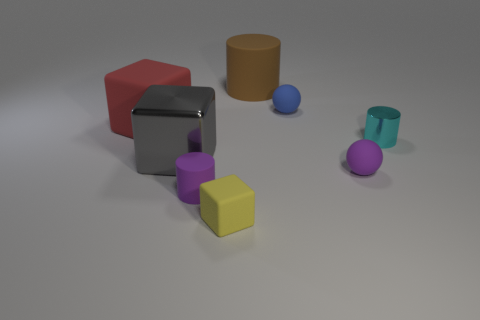What is the shape of the large rubber thing that is to the left of the yellow block?
Your answer should be compact. Cube. There is a cylinder in front of the small purple ball; is it the same color as the tiny matte ball in front of the big metal thing?
Provide a succinct answer. Yes. What is the size of the thing that is the same color as the tiny rubber cylinder?
Make the answer very short. Small. Are any big cyan metallic spheres visible?
Offer a terse response. No. There is a small purple object on the right side of the tiny object that is behind the rubber block that is left of the large shiny thing; what shape is it?
Your answer should be very brief. Sphere. How many blue rubber balls are behind the tiny yellow matte thing?
Your answer should be compact. 1. Is the tiny purple thing to the left of the brown cylinder made of the same material as the gray thing?
Make the answer very short. No. How many other objects are there of the same shape as the blue matte object?
Your response must be concise. 1. How many cyan shiny cylinders are to the right of the big cube that is behind the small cylinder that is behind the small rubber cylinder?
Make the answer very short. 1. What is the color of the small cylinder that is on the left side of the brown matte object?
Your answer should be compact. Purple. 